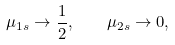Convert formula to latex. <formula><loc_0><loc_0><loc_500><loc_500>\mu _ { 1 s } \rightarrow \frac { 1 } { 2 } , \quad \mu _ { 2 s } \rightarrow 0 ,</formula> 